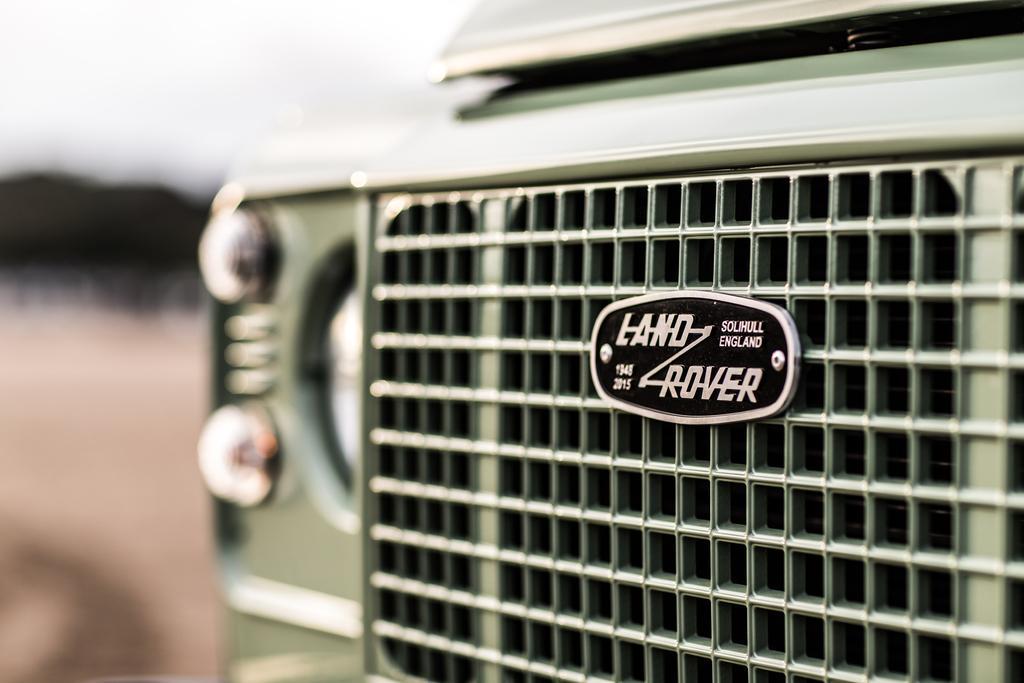How would you summarize this image in a sentence or two? It is a zoomed in picture of a land rover vehicle and the background is blurred. 